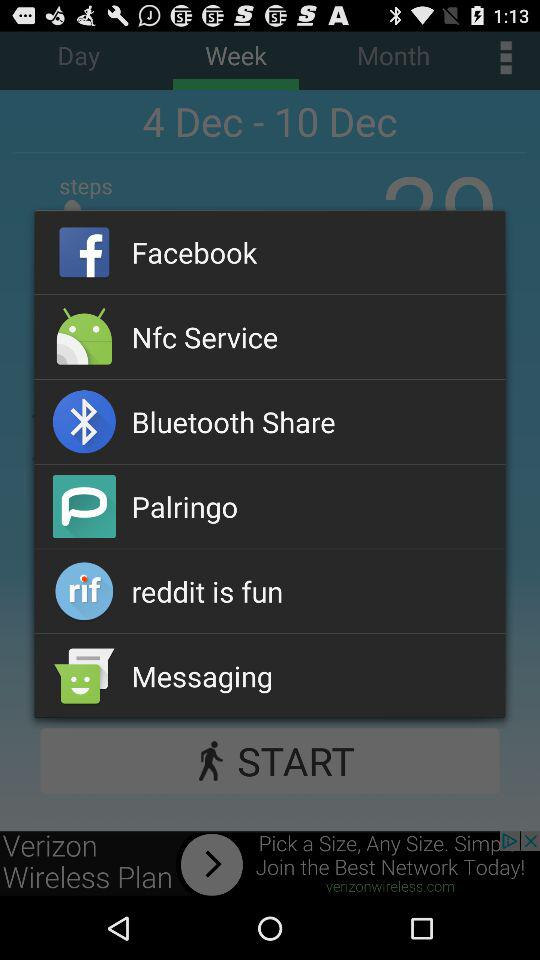What are the different apps to share? The apps are "Facebook", "Nfc Service", "Bluetooth Share", "Palringo", "reddit is fun", and "Messaging". 